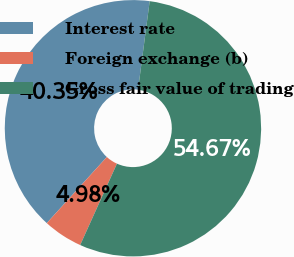Convert chart to OTSL. <chart><loc_0><loc_0><loc_500><loc_500><pie_chart><fcel>Interest rate<fcel>Foreign exchange (b)<fcel>Gross fair value of trading<nl><fcel>40.35%<fcel>4.98%<fcel>54.67%<nl></chart> 